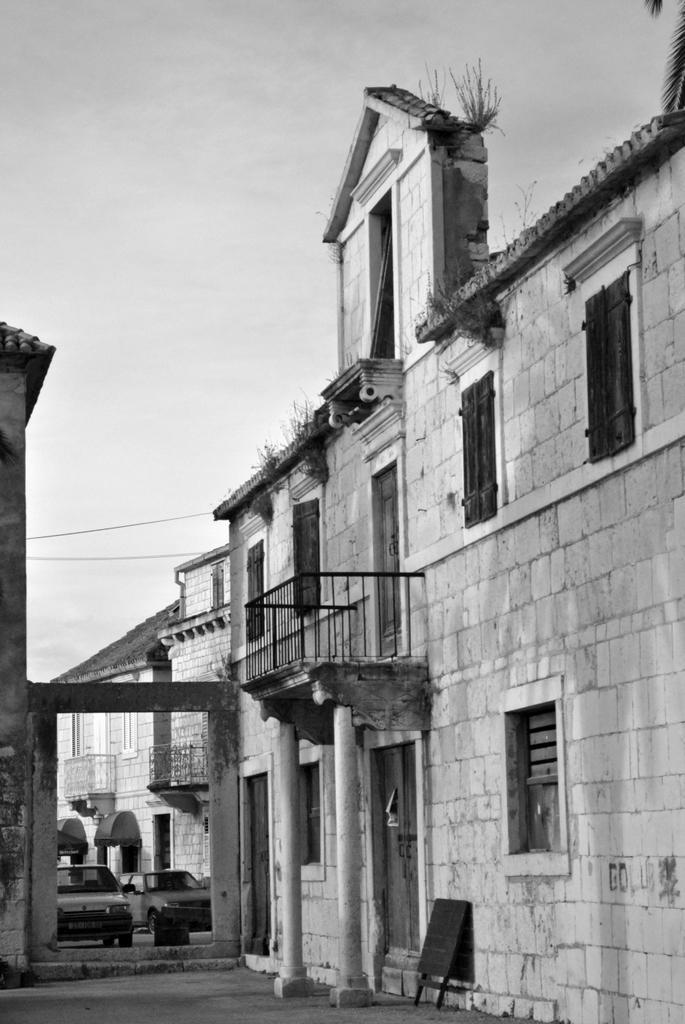Can you describe this image briefly? In this picture we can see buildings, railings, windows, pillars, cars, board on the ground and grass. In the background of the image we can see the sky. In the top right corner of the image we can see leaves. 